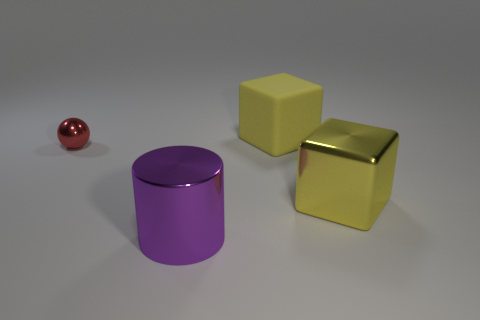Add 3 small yellow rubber blocks. How many objects exist? 7 Subtract all spheres. How many objects are left? 3 Subtract all tiny spheres. Subtract all small metallic things. How many objects are left? 2 Add 3 shiny things. How many shiny things are left? 6 Add 4 large rubber cubes. How many large rubber cubes exist? 5 Subtract 0 purple spheres. How many objects are left? 4 